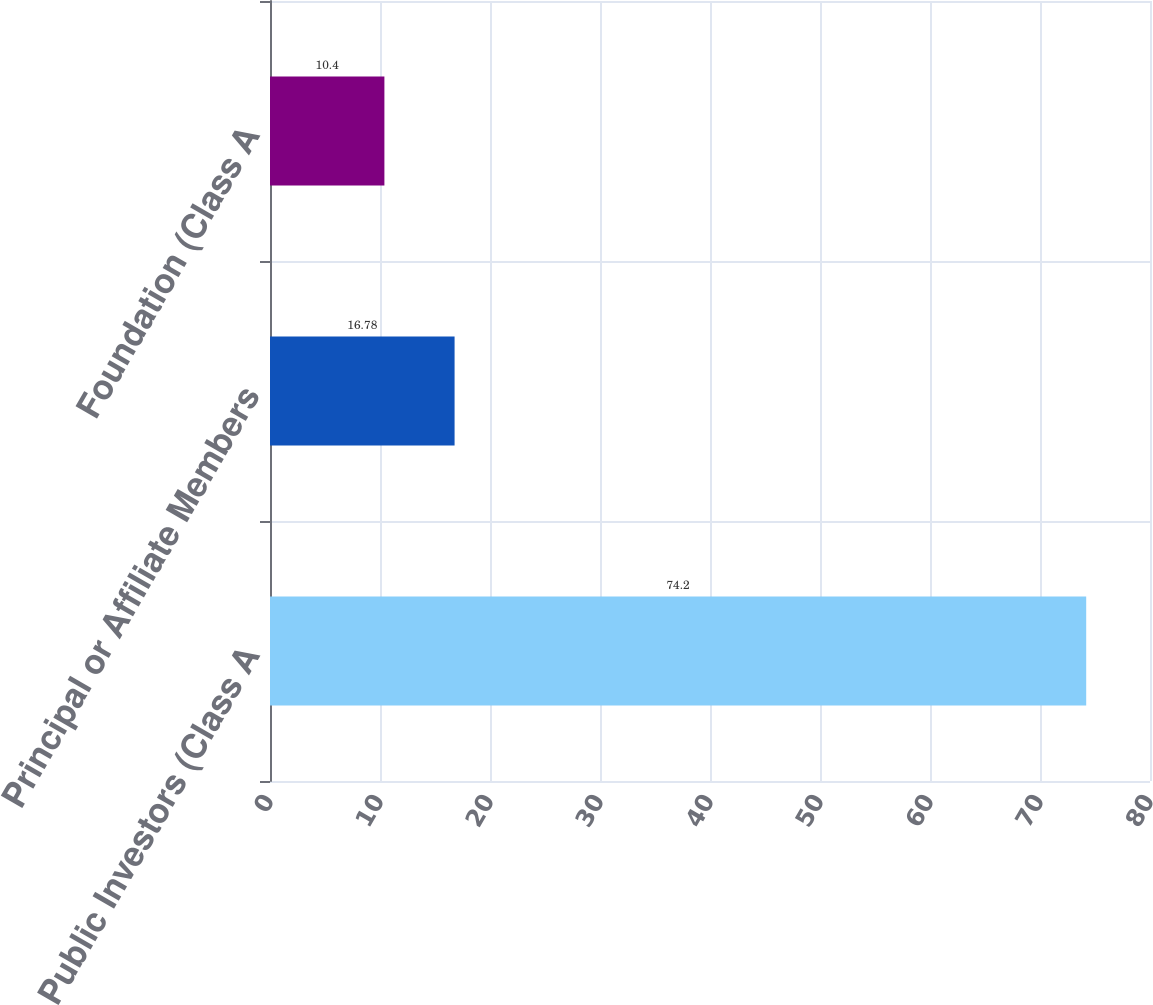Convert chart. <chart><loc_0><loc_0><loc_500><loc_500><bar_chart><fcel>Public Investors (Class A<fcel>Principal or Affiliate Members<fcel>Foundation (Class A<nl><fcel>74.2<fcel>16.78<fcel>10.4<nl></chart> 